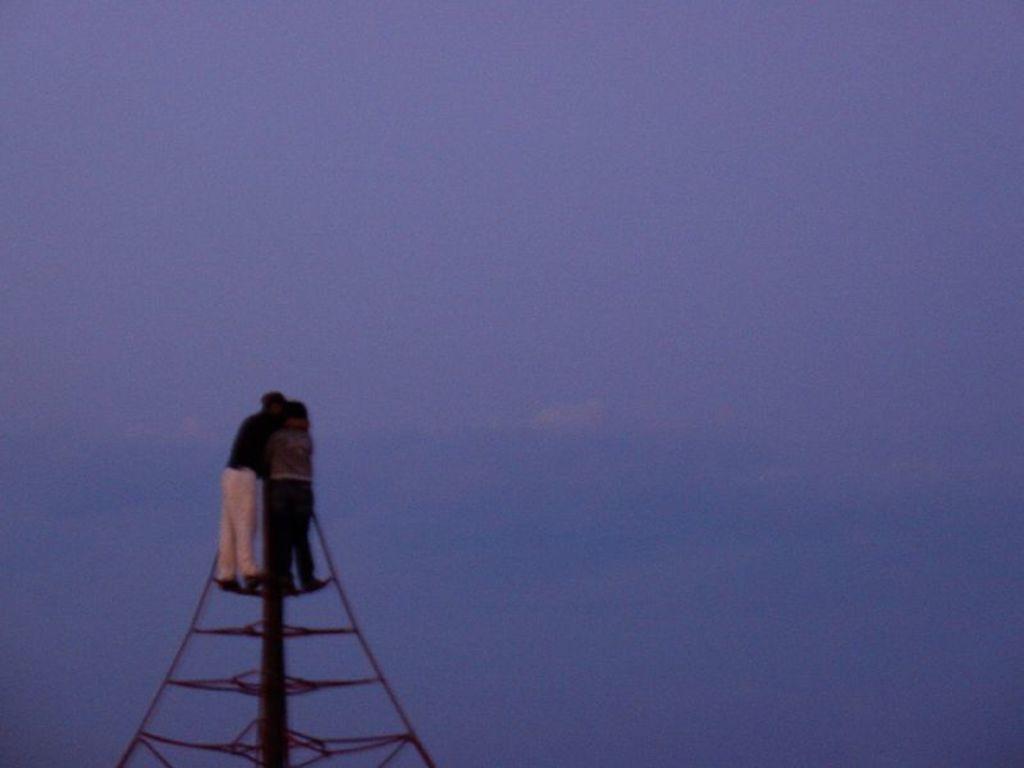Please provide a concise description of this image. At the bottom of the picture, we see two men are standing on the tower. In the background, we see the sky, which is blue in color. 